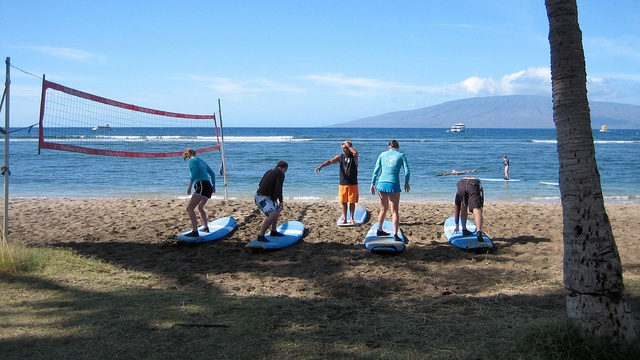Describe the objects in this image and their specific colors. I can see people in lightblue, maroon, blue, and teal tones, people in lightblue, black, gray, and navy tones, people in lightblue, black, blue, navy, and teal tones, people in lightblue, black, gray, purple, and tan tones, and people in lightblue, black, maroon, gray, and brown tones in this image. 